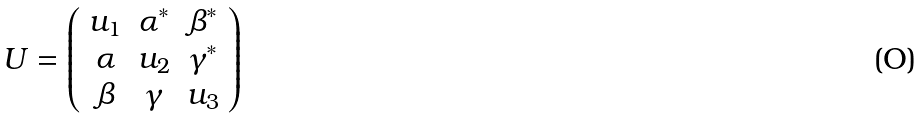<formula> <loc_0><loc_0><loc_500><loc_500>U = \left ( \begin{array} { c c c } u _ { 1 } & \alpha ^ { * } & \beta ^ { * } \\ \alpha & u _ { 2 } & \gamma ^ { * } \\ \beta & \gamma & u _ { 3 } \end{array} \right )</formula> 